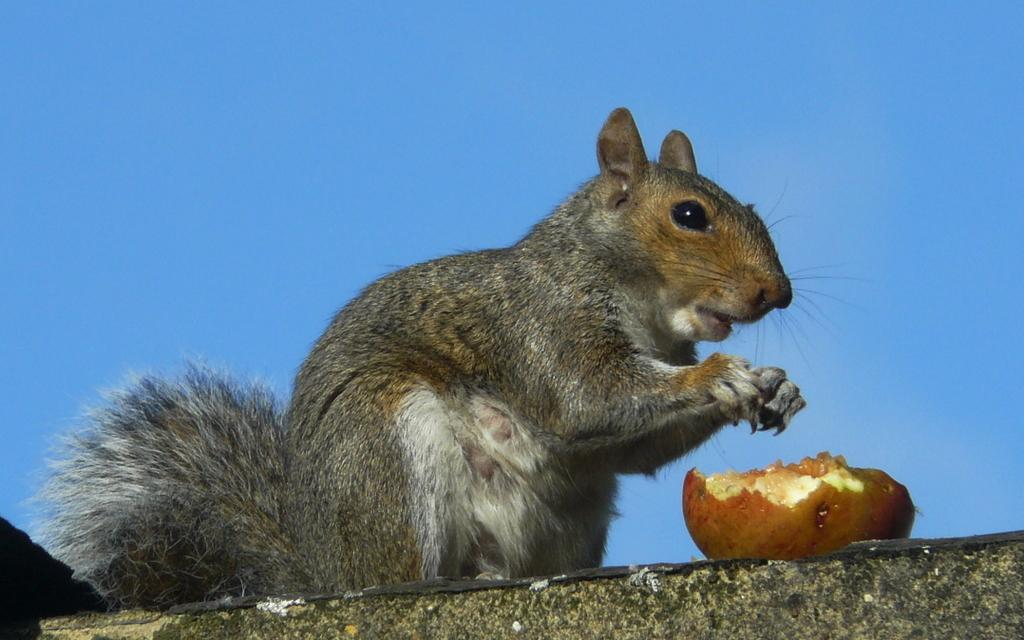What animal can be seen on the wall in the image? There is a squirrel on the wall in the image. What type of food is present in the image? There is a half-eaten fruit in the image. What can be seen in the background of the image? The sky is visible in the background of the image. What is the color of the sky in the image? The sky is blue in color in the image. What type of appliance can be seen in the image? There is no appliance present in the image. Is there any ink visible in the image? There is no ink visible in the image. 